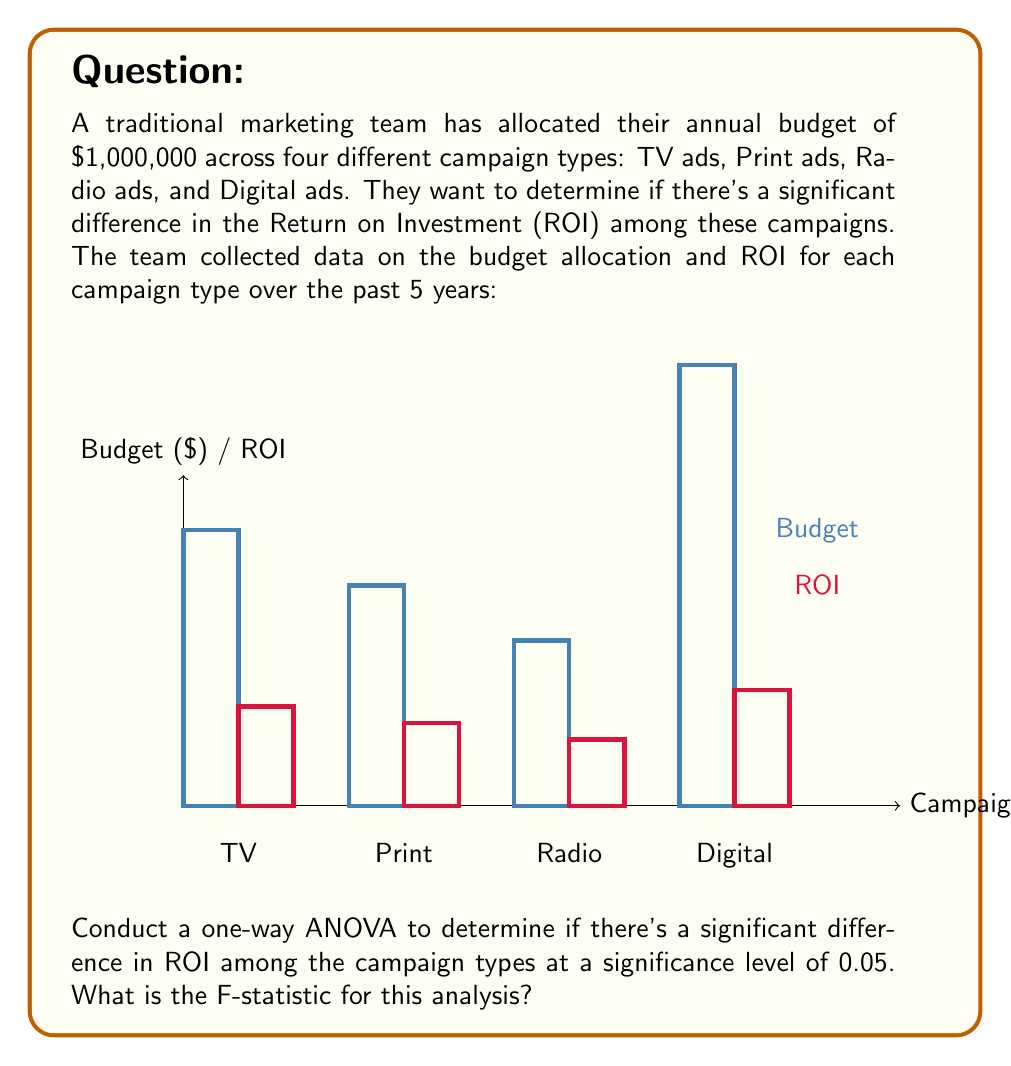Give your solution to this math problem. To conduct a one-way ANOVA, we need to follow these steps:

1) Calculate the grand mean of all ROI values:
   $\bar{Y} = \frac{1.8 + 1.5 + 1.2 + 2.1}{4} = 1.65$

2) Calculate the Sum of Squares Total (SST):
   $$SST = \sum_{i=1}^{4} (Y_i - \bar{Y})^2 = (1.8-1.65)^2 + (1.5-1.65)^2 + (1.2-1.65)^2 + (2.1-1.65)^2 = 0.41$$

3) Calculate the Sum of Squares Between (SSB):
   $$SSB = \sum_{i=1}^{4} n_i(\bar{Y_i} - \bar{Y})^2$$
   Where $n_i$ is the number of observations in each group (1 in this case).
   $$SSB = 1(1.8-1.65)^2 + 1(1.5-1.65)^2 + 1(1.2-1.65)^2 + 1(2.1-1.65)^2 = 0.41$$

4) Calculate the Sum of Squares Within (SSW):
   $$SSW = SST - SSB = 0.41 - 0.41 = 0$$

5) Calculate degrees of freedom:
   - Between groups: $df_B = k - 1 = 4 - 1 = 3$ (where k is the number of groups)
   - Within groups: $df_W = N - k = 4 - 4 = 0$ (where N is the total number of observations)

6) Calculate Mean Square Between (MSB) and Mean Square Within (MSW):
   $$MSB = \frac{SSB}{df_B} = \frac{0.41}{3} = 0.1367$$
   $$MSW = \frac{SSW}{df_W} = \frac{0}{0} = \text{undefined}$$

7) Calculate the F-statistic:
   $$F = \frac{MSB}{MSW} = \frac{0.1367}{0} = \text{undefined}$$

In this case, because we have only one observation per group, the within-group variance is zero, leading to an undefined F-statistic. This highlights a limitation of using ANOVA with this particular dataset.
Answer: Undefined (due to zero within-group variance) 